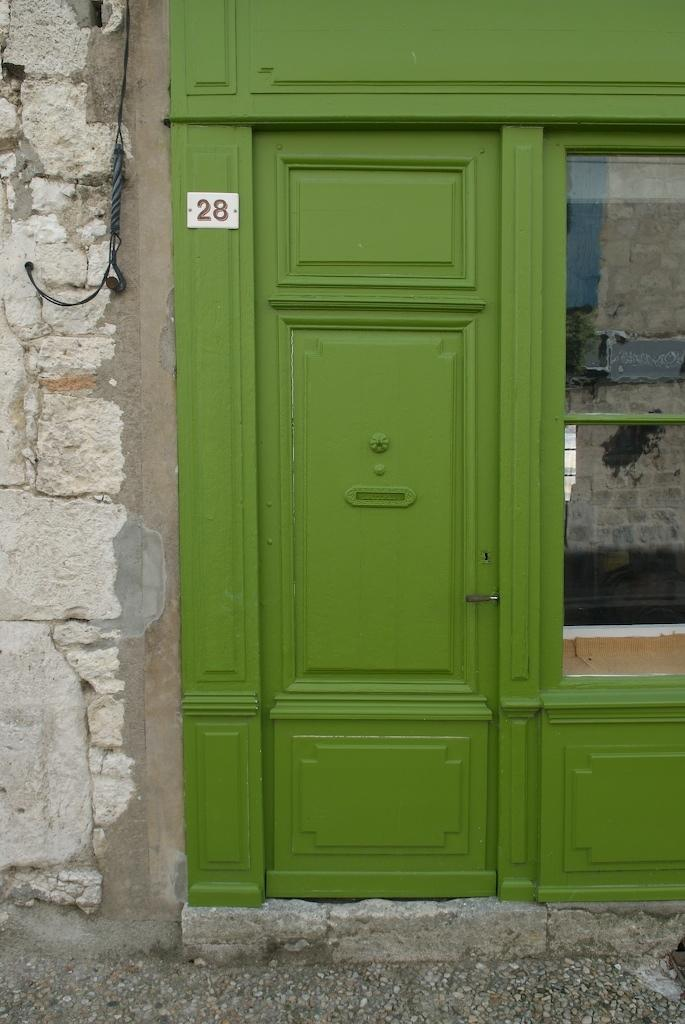What type of structure can be seen in the image? There is a wall visible in the image. What is the color of the door in the image? There is a green-colored door in the image. What type of opening is present in the wall? There is a glass window visible in the image. Can you tell me how many buttons are on the street in the image? There is no street or buttons present in the image. What type of waste is visible in the image? There is no waste visible in the image. 